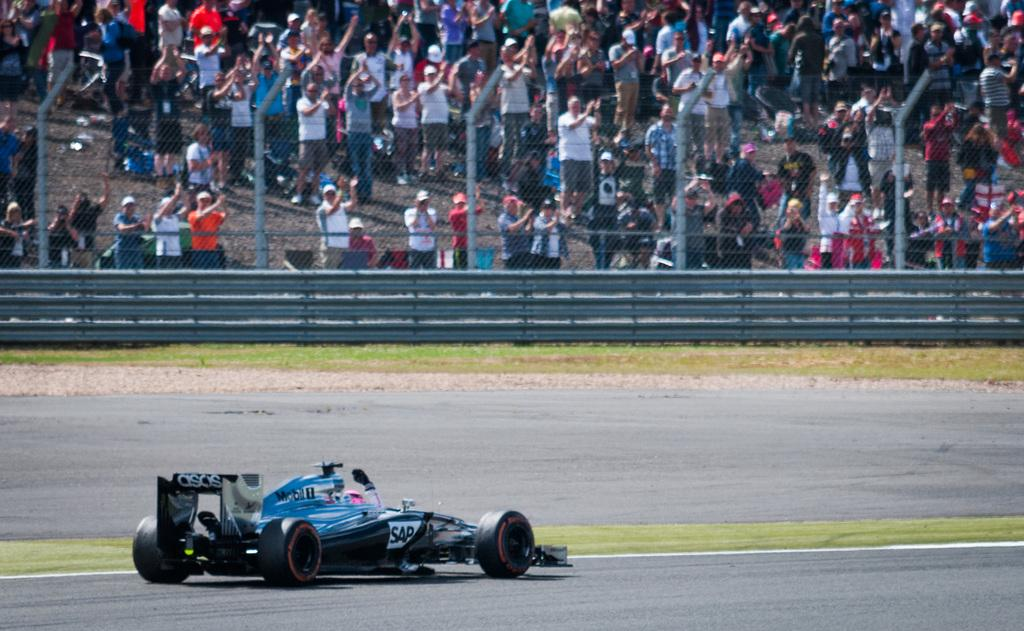What is on the road in the image? There is a vehicle on the road in the image. What type of vegetation can be seen in the image? There is grass visible in the image. What is separating the grass from the road in the image? There is a fence in the image. What are the tall, thin structures in the image? There are poles in the image. What can be seen in the background of the image? There is a group of people standing in the background of the image. What type of pan is being used to cook food in the image? There is no pan or cooking activity present in the image. What type of building can be seen in the background of the image? There is no building visible in the image; only a group of people standing in the background. 